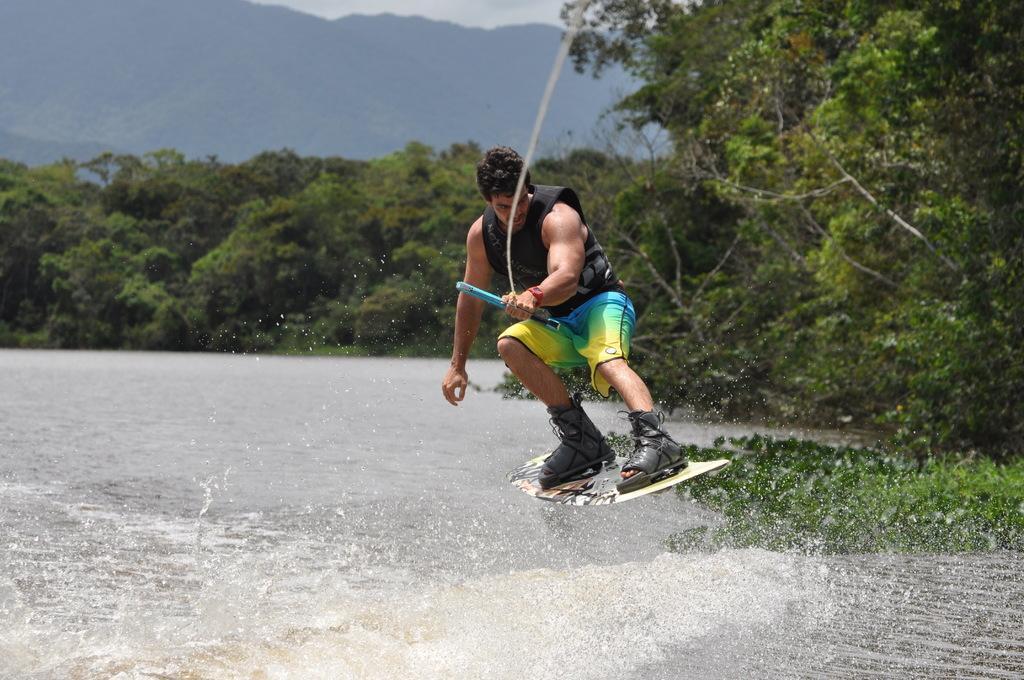Could you give a brief overview of what you see in this image? In this image there is a man with a surfboard is holding a rope , and there is water , trees, hills, sky. 